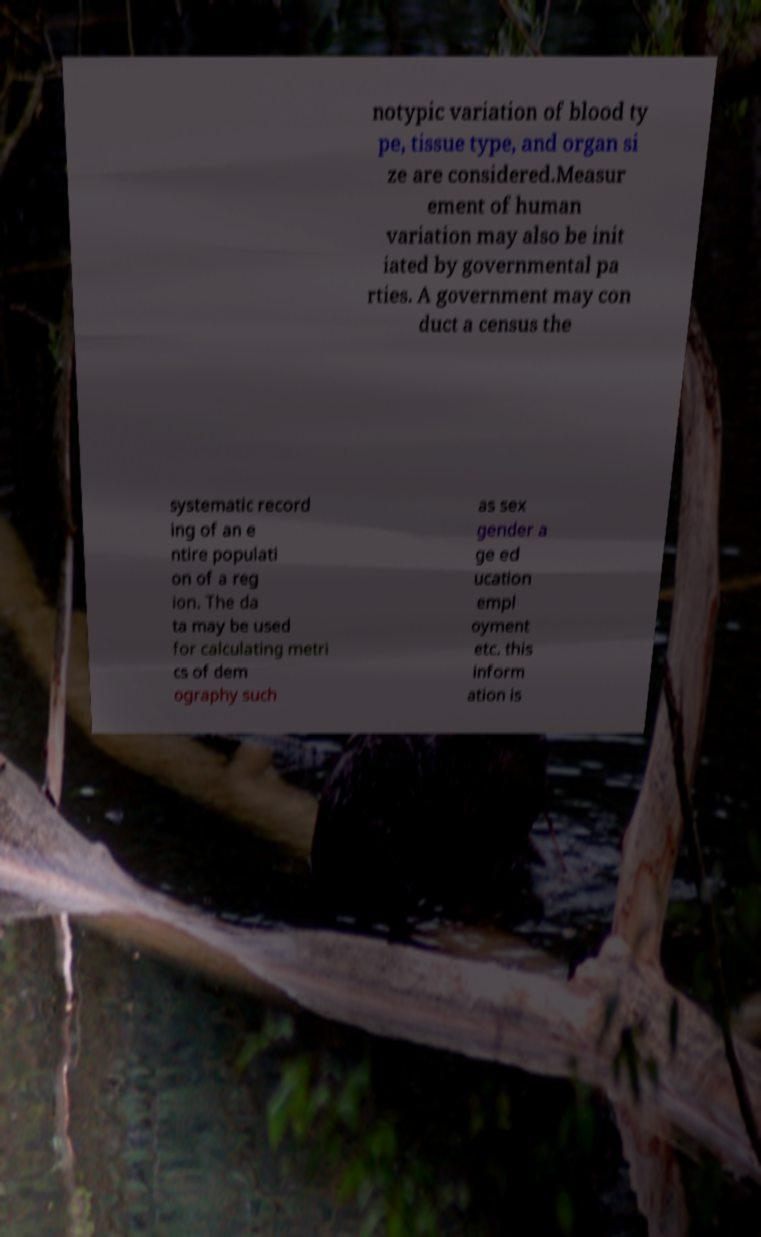Please read and relay the text visible in this image. What does it say? notypic variation of blood ty pe, tissue type, and organ si ze are considered.Measur ement of human variation may also be init iated by governmental pa rties. A government may con duct a census the systematic record ing of an e ntire populati on of a reg ion. The da ta may be used for calculating metri cs of dem ography such as sex gender a ge ed ucation empl oyment etc. this inform ation is 